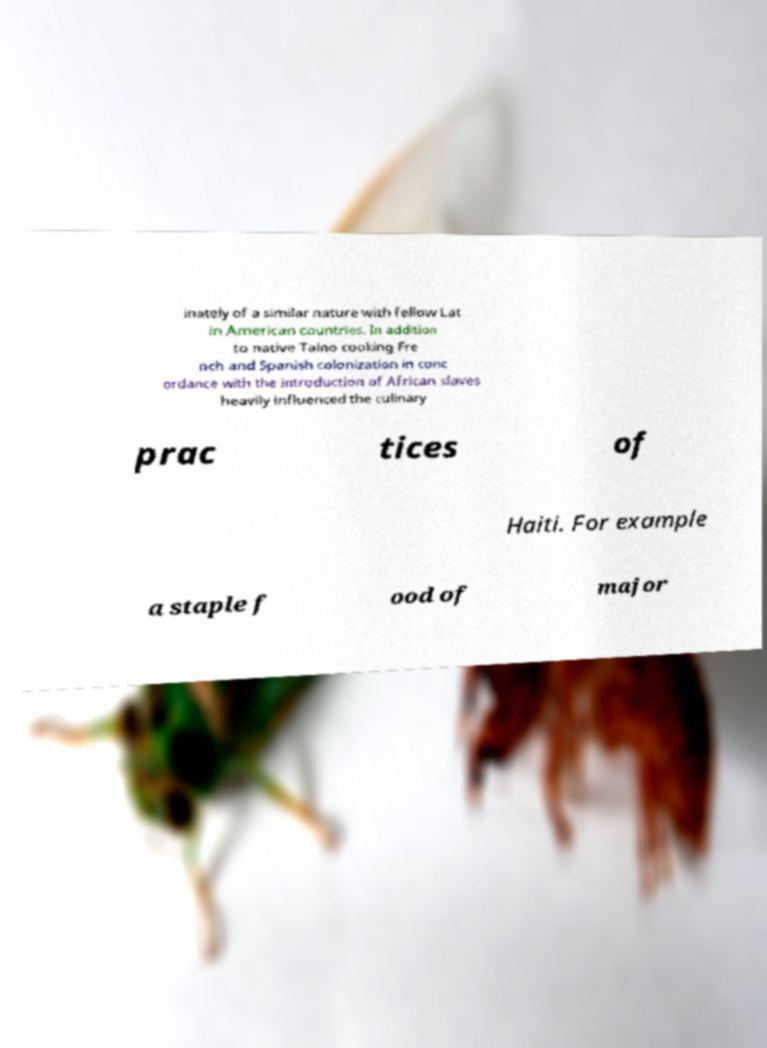For documentation purposes, I need the text within this image transcribed. Could you provide that? inately of a similar nature with fellow Lat in American countries. In addition to native Taino cooking Fre nch and Spanish colonization in conc ordance with the introduction of African slaves heavily influenced the culinary prac tices of Haiti. For example a staple f ood of major 